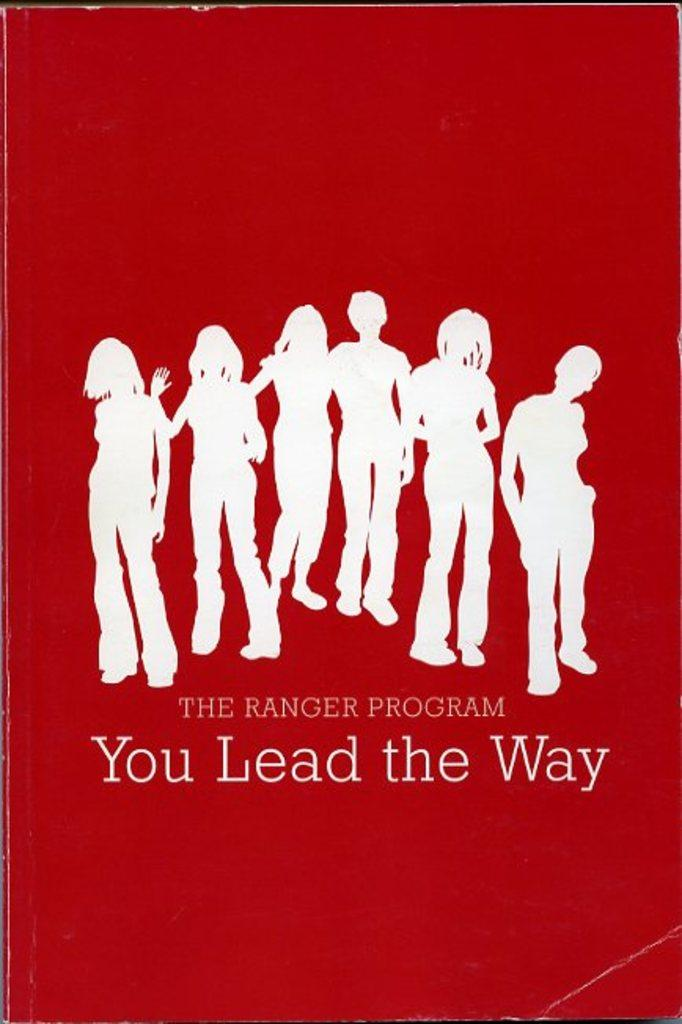What is the main subject of the image? The image contains the cover page of a book. What can be seen on the cover page? There are images of people on the cover page. Is there any text on the cover page? Yes, there is text on the cover page. What is the design of the calendar on the cover page? There is no calendar present on the cover page; it features images of people and text. What is the rate of the design on the cover page? The concept of a "rate" does not apply to the design of the cover page, as it is a static image and not a service or product with a price. 